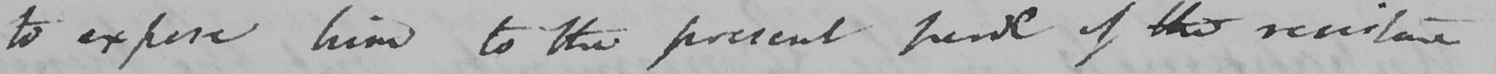Can you read and transcribe this handwriting? to expose him to the present trend of the resistance 